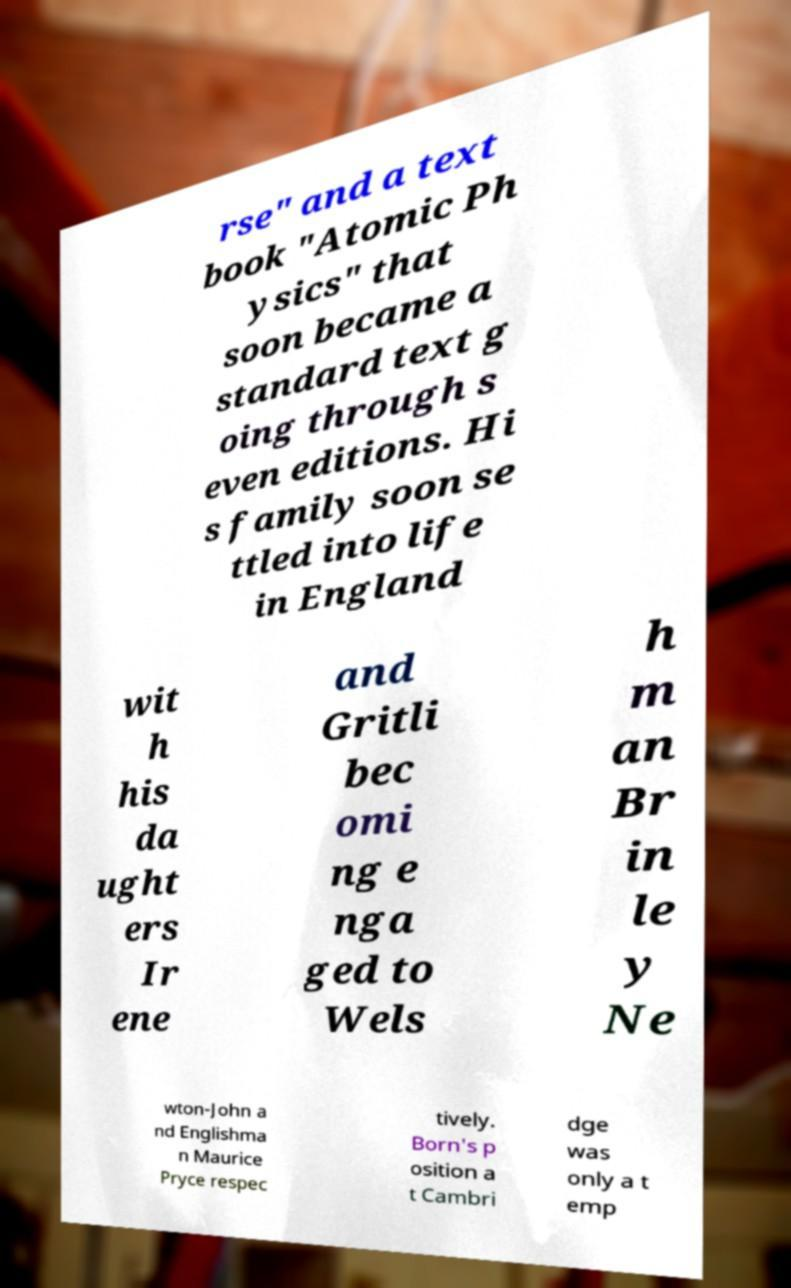What messages or text are displayed in this image? I need them in a readable, typed format. rse" and a text book "Atomic Ph ysics" that soon became a standard text g oing through s even editions. Hi s family soon se ttled into life in England wit h his da ught ers Ir ene and Gritli bec omi ng e nga ged to Wels h m an Br in le y Ne wton-John a nd Englishma n Maurice Pryce respec tively. Born's p osition a t Cambri dge was only a t emp 